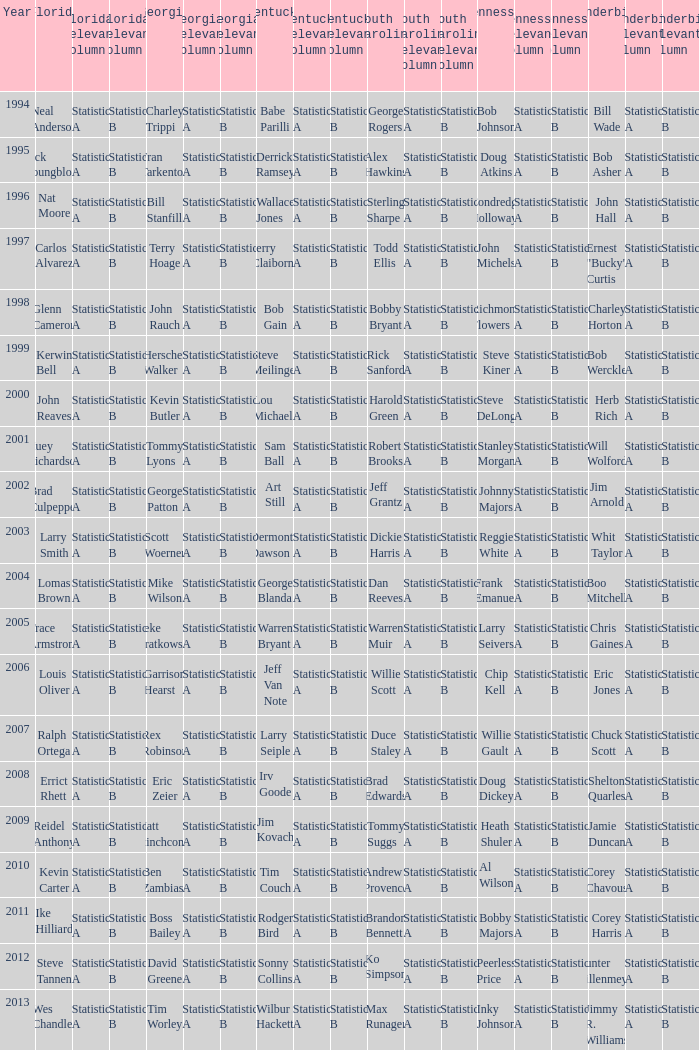What is the total Year of jeff van note ( Kentucky) 2006.0. 